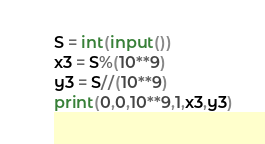Convert code to text. <code><loc_0><loc_0><loc_500><loc_500><_Python_>S = int(input())
x3 = S%(10**9)
y3 = S//(10**9)
print(0,0,10**9,1,x3,y3)</code> 